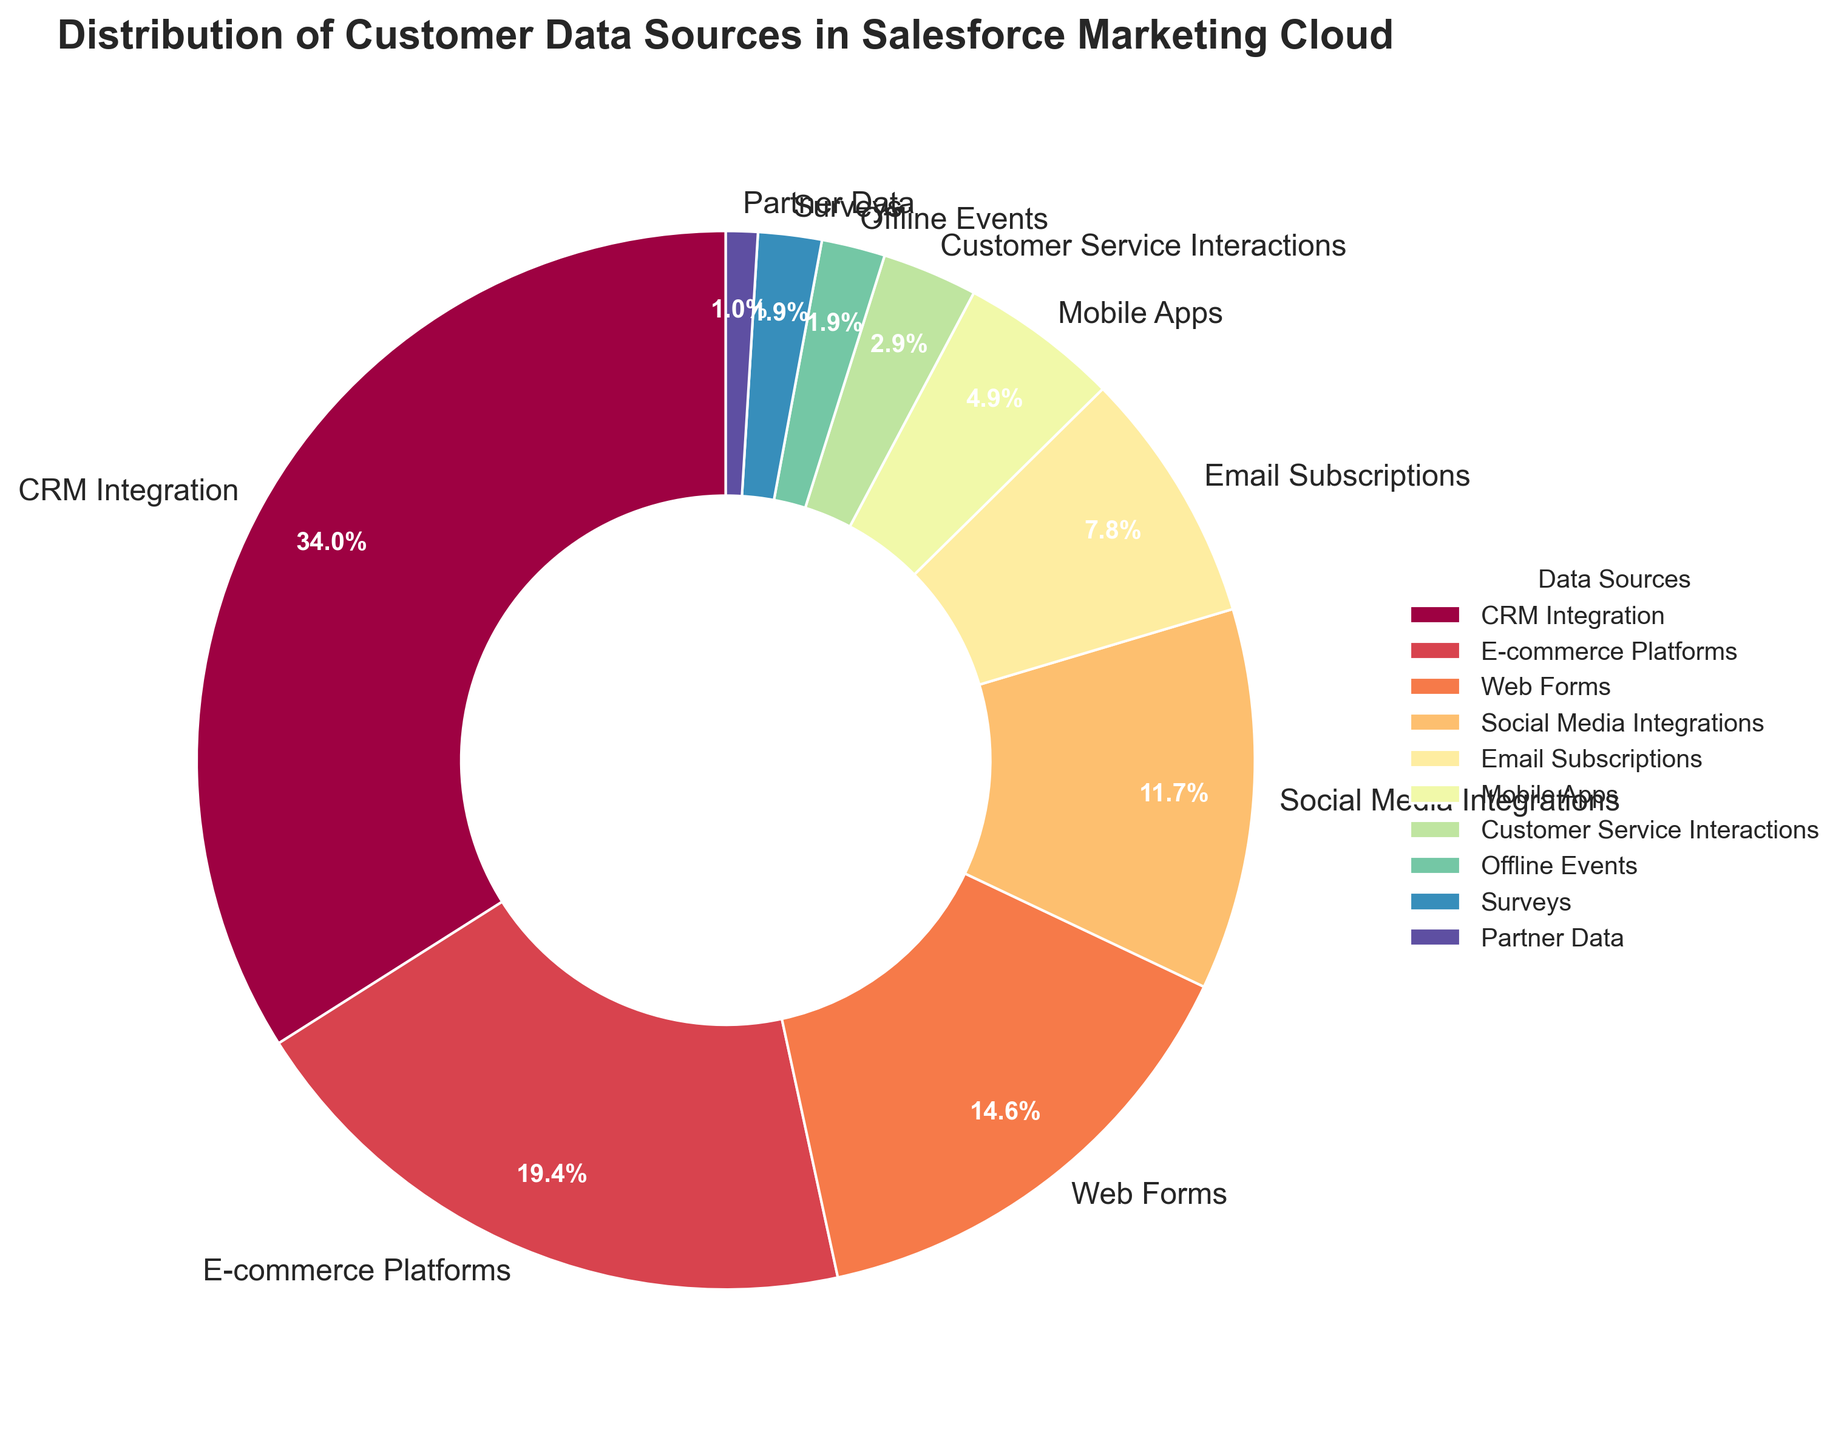What are the two largest data sources? To find the largest data sources, look for the slices with the highest percentages. The labels or legend can help identify them. The two largest slices represent CRM Integration (35%) and E-commerce Platforms (20%).
Answer: CRM Integration and E-commerce Platforms What percentage of the data sources come from Social Media Integrations and Email Subscriptions combined? Locate the percentages for Social Media Integrations (12%) and Email Subscriptions (8%). Add these percentages together: 12% + 8% = 20%.
Answer: 20% Which data source has the smallest contribution? Identify the slice with the smallest percentage or find it in the legend. Partner Data has the smallest contribution at 1%.
Answer: Partner Data How much greater is the CRM Integration percentage compared to the Web Forms percentage? Locate the percentages for CRM Integration (35%) and Web Forms (15%). Subtract the Web Forms percentage from CRM Integration: 35% - 15% = 20%.
Answer: 20% What is the combined percentage of data sources under 5%? Find the data sources below 5%: Customer Service Interactions (3%), Offline Events (2%), Surveys (2%), and Partner Data (1%). Add these percentages together: 3% + 2% + 2% + 1% = 8%.
Answer: 8% Which data sources have a percentage greater than E-commerce Platforms? Locate the percentage for E-commerce Platforms (20%) and identify data sources with higher percentages. CRM Integration (35%) is the only one above 20%.
Answer: CRM Integration What are the three smallest data sources combined? Identify the smallest percentages: Partner Data (1%), Surveys (2%), and Offline Events (2%). Add these percentages together: 1% + 2% + 2% = 5%.
Answer: 5% Does the slice for Mobile Apps appear larger or smaller than the slice for Social Media Integrations? Visually compare the slice sizes for Mobile Apps (5%) and Social Media Integrations (12%). The slice for Social Media Integrations is larger than the slice for Mobile Apps.
Answer: Smaller What is the total percentage contributed by Offline Events, Surveys, and Partner Data? Add the percentages for Offline Events (2%), Surveys (2%), and Partner Data (1%): 2% + 2% + 1% = 5%.
Answer: 5% Is there any single data source that contributes more than 30%? Check each data source's percentage. CRM Integration is the only one above 30%, contributing 35%.
Answer: Yes, CRM Integration 